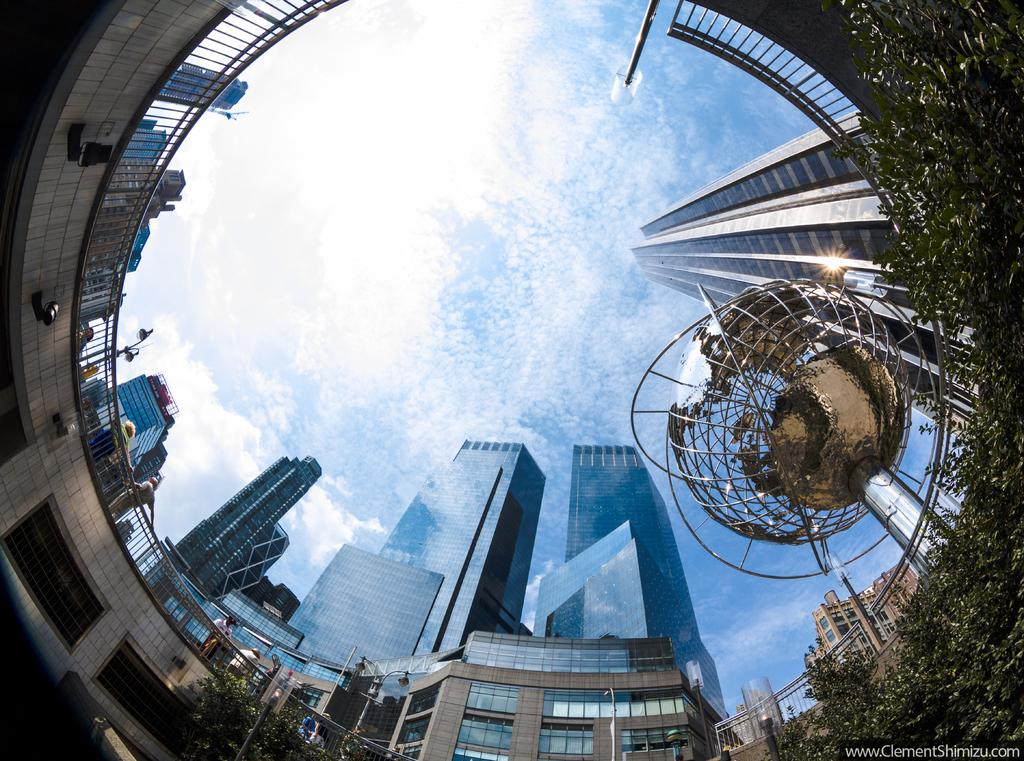What type of structures can be seen in the image? There are buildings and skyscrapers in the image. What else can be seen in the image besides the buildings? There are trees in the image. What is visible in the background of the image? The sky is visible in the image, and clouds are present in the sky. What type of fruit can be seen hanging from the trees in the image? There is no fruit visible in the image, as it only shows trees without any fruit. 